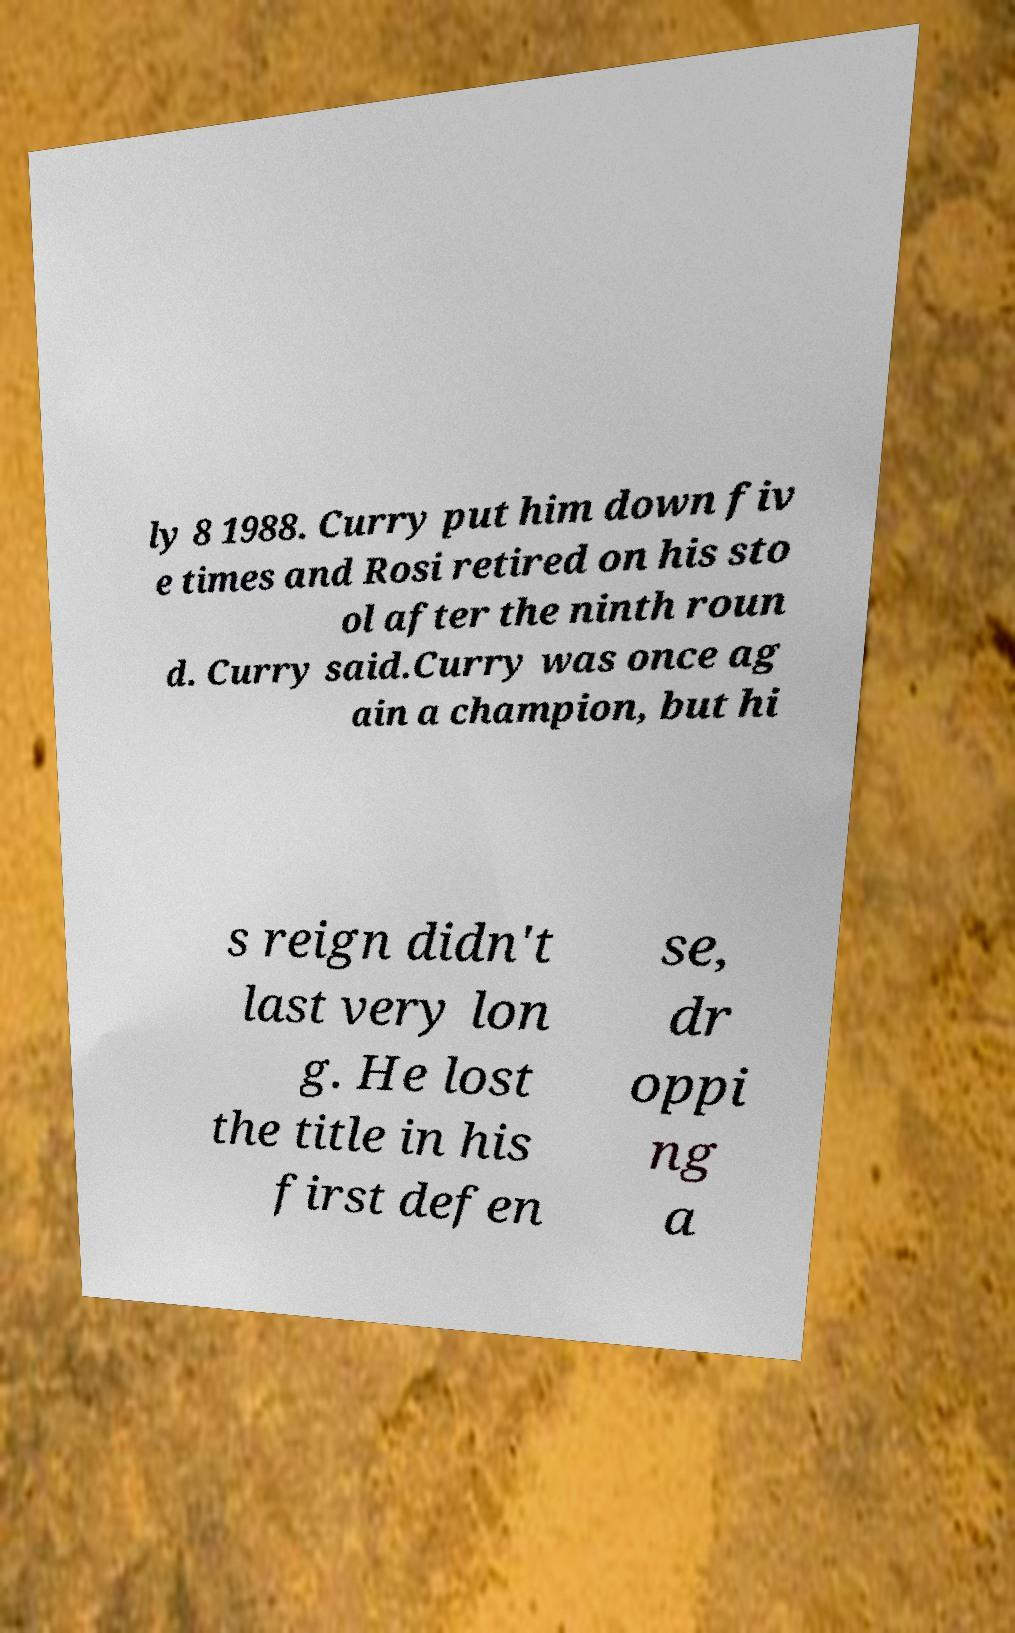For documentation purposes, I need the text within this image transcribed. Could you provide that? ly 8 1988. Curry put him down fiv e times and Rosi retired on his sto ol after the ninth roun d. Curry said.Curry was once ag ain a champion, but hi s reign didn't last very lon g. He lost the title in his first defen se, dr oppi ng a 